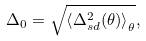Convert formula to latex. <formula><loc_0><loc_0><loc_500><loc_500>\Delta _ { 0 } = \sqrt { \left \langle \Delta _ { s d } ^ { 2 } ( \theta ) \right \rangle _ { \theta } } ,</formula> 